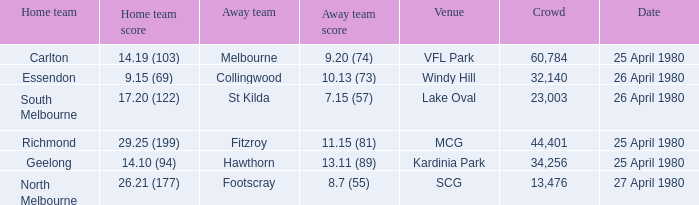Would you be able to parse every entry in this table? {'header': ['Home team', 'Home team score', 'Away team', 'Away team score', 'Venue', 'Crowd', 'Date'], 'rows': [['Carlton', '14.19 (103)', 'Melbourne', '9.20 (74)', 'VFL Park', '60,784', '25 April 1980'], ['Essendon', '9.15 (69)', 'Collingwood', '10.13 (73)', 'Windy Hill', '32,140', '26 April 1980'], ['South Melbourne', '17.20 (122)', 'St Kilda', '7.15 (57)', 'Lake Oval', '23,003', '26 April 1980'], ['Richmond', '29.25 (199)', 'Fitzroy', '11.15 (81)', 'MCG', '44,401', '25 April 1980'], ['Geelong', '14.10 (94)', 'Hawthorn', '13.11 (89)', 'Kardinia Park', '34,256', '25 April 1980'], ['North Melbourne', '26.21 (177)', 'Footscray', '8.7 (55)', 'SCG', '13,476', '27 April 1980']]} What wa the date of the North Melbourne home game? 27 April 1980. 